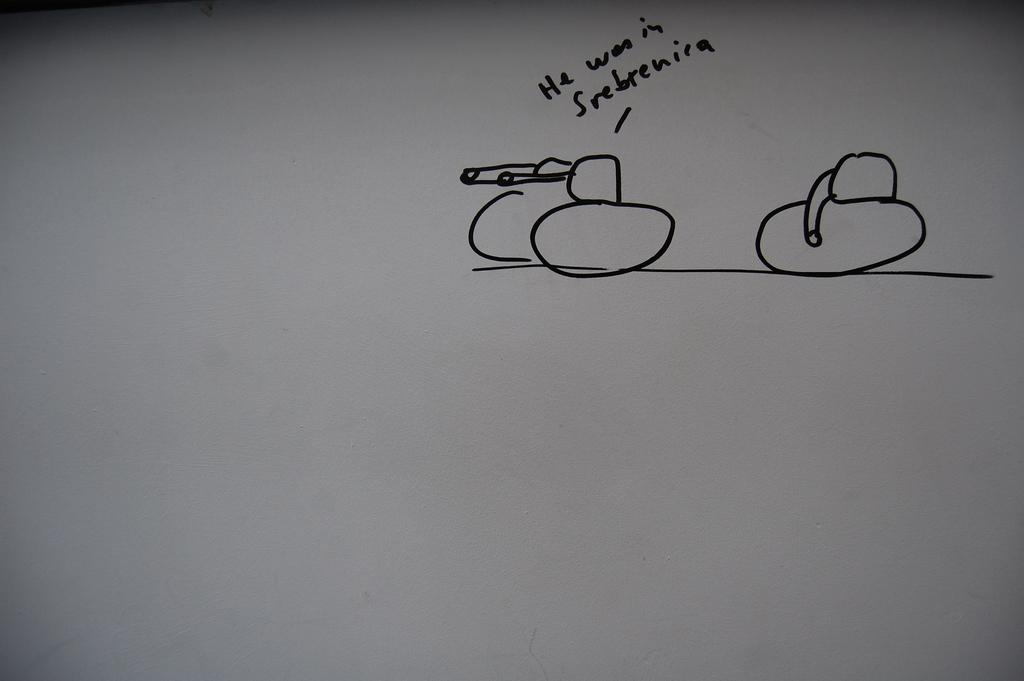<image>
Describe the image concisely. A child like drawing, on white paper is pointing to a round object with the words He was in Srebrenira. 